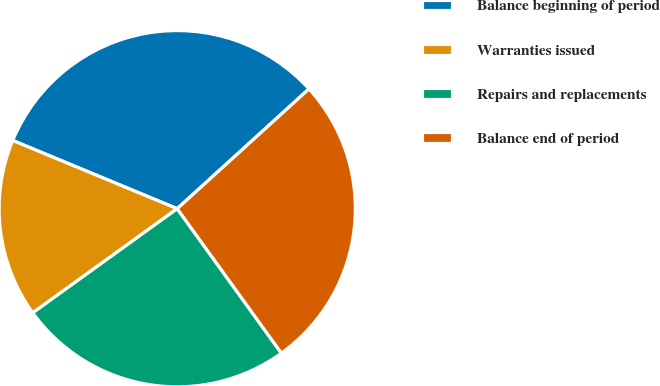Convert chart. <chart><loc_0><loc_0><loc_500><loc_500><pie_chart><fcel>Balance beginning of period<fcel>Warranties issued<fcel>Repairs and replacements<fcel>Balance end of period<nl><fcel>32.0%<fcel>16.2%<fcel>25.0%<fcel>26.8%<nl></chart> 